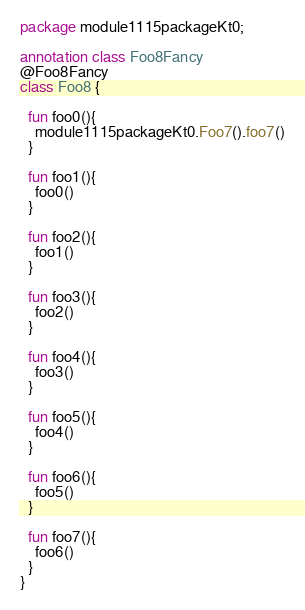Convert code to text. <code><loc_0><loc_0><loc_500><loc_500><_Kotlin_>package module1115packageKt0;

annotation class Foo8Fancy
@Foo8Fancy
class Foo8 {

  fun foo0(){
    module1115packageKt0.Foo7().foo7()
  }

  fun foo1(){
    foo0()
  }

  fun foo2(){
    foo1()
  }

  fun foo3(){
    foo2()
  }

  fun foo4(){
    foo3()
  }

  fun foo5(){
    foo4()
  }

  fun foo6(){
    foo5()
  }

  fun foo7(){
    foo6()
  }
}</code> 